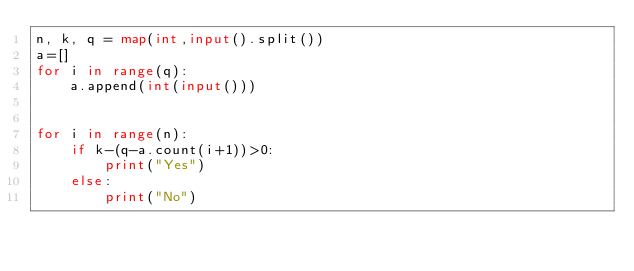Convert code to text. <code><loc_0><loc_0><loc_500><loc_500><_Python_>n, k, q = map(int,input().split())
a=[]
for i in range(q):
    a.append(int(input()))

    
for i in range(n):
    if k-(q-a.count(i+1))>0:
        print("Yes")
    else:
        print("No")</code> 